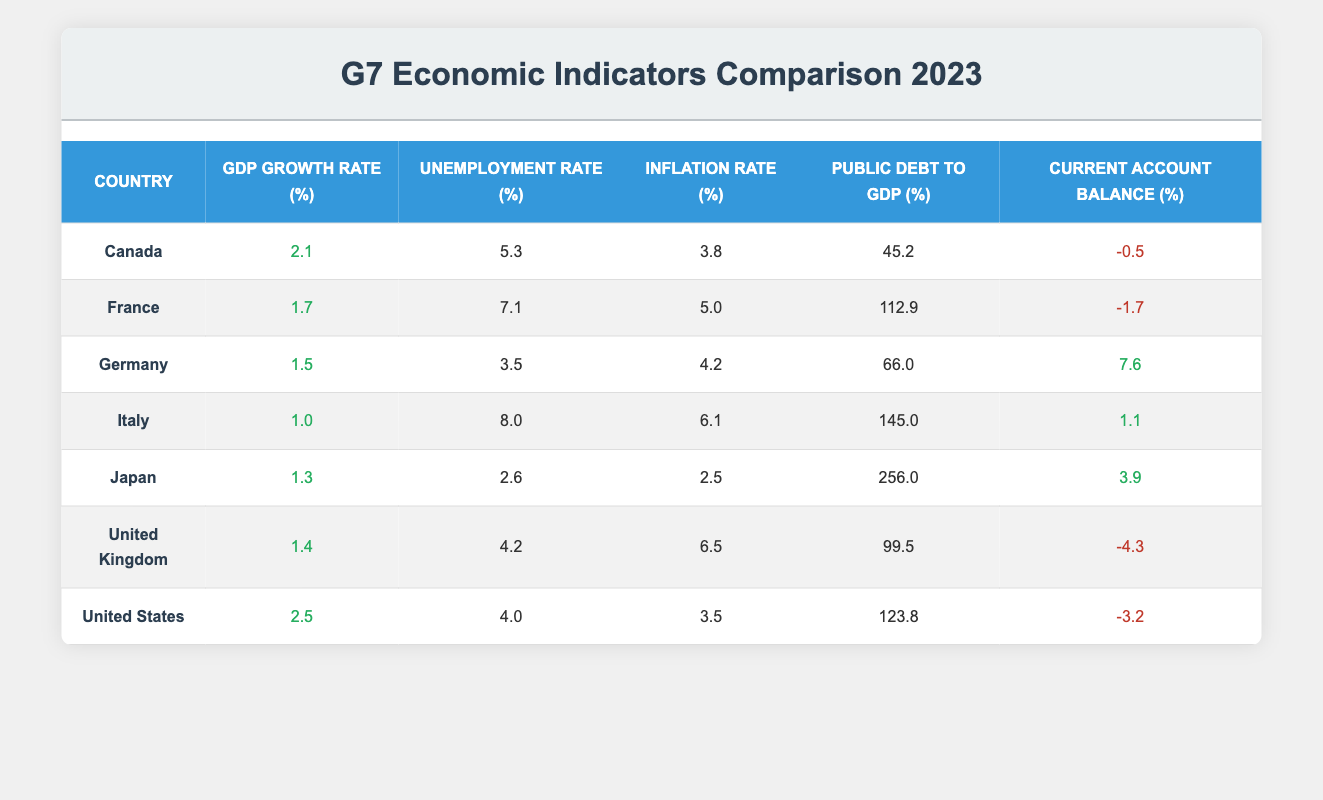What is the GDP growth rate of Canada? From the table, Canada has a GDP Growth Rate of 2.1%. This value is found in the row corresponding to Canada and in the second column labeled "GDP Growth Rate (%)".
Answer: 2.1% Which country has the highest unemployment rate in 2023? The unemployment rates listed in the table are: Canada (5.3%), France (7.1%), Germany (3.5%), Italy (8.0%), Japan (2.6%), United Kingdom (4.2%), and United States (4.0%). The highest rate is 8.0% from Italy.
Answer: Italy Is the current account balance of Japan positive or negative? The Current Account Balance for Japan is listed as 3.9%. Since this value is greater than zero, it indicates a positive balance.
Answer: Positive What is the difference in inflation rates between the highest and lowest values in the G7 countries? The highest inflation rate is in Italy at 6.1%, and the lowest is in Japan at 2.5%. The difference is calculated as 6.1% - 2.5% = 3.6%.
Answer: 3.6% What is the average unemployment rate across the G7 countries? The unemployment rates are: 5.3% (Canada), 7.1% (France), 3.5% (Germany), 8.0% (Italy), 2.6% (Japan), 4.2% (United Kingdom), and 4.0% (United States). The total is 5.3 + 7.1 + 3.5 + 8.0 + 2.6 + 4.2 + 4.0 = 34.7%, and since there are 7 countries, we calculate the average as 34.7 / 7 ≈ 4.96%.
Answer: 4.96% Does Germany have a higher GDP growth rate than France? Germany's GDP Growth Rate is 1.5% and France's is 1.7%. Since 1.5% is less than 1.7%, the statement is false.
Answer: No 